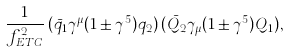<formula> <loc_0><loc_0><loc_500><loc_500>\frac { 1 } { f _ { E T C } ^ { 2 } } \, ( \bar { q _ { 1 } } \gamma ^ { \mu } ( 1 \pm \gamma ^ { 5 } ) q _ { 2 } ) \, ( \bar { Q _ { 2 } } \gamma _ { \mu } ( 1 \pm \gamma ^ { 5 } ) Q _ { 1 } ) ,</formula> 